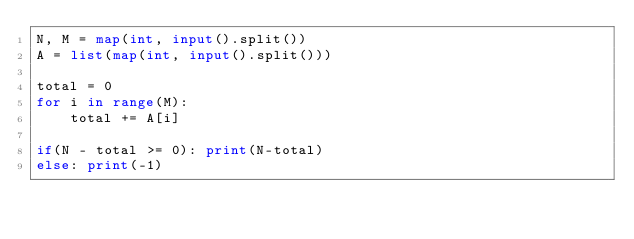Convert code to text. <code><loc_0><loc_0><loc_500><loc_500><_Python_>N, M = map(int, input().split())
A = list(map(int, input().split()))
 
total = 0
for i in range(M):
    total += A[i]
 
if(N - total >= 0): print(N-total)
else: print(-1)</code> 